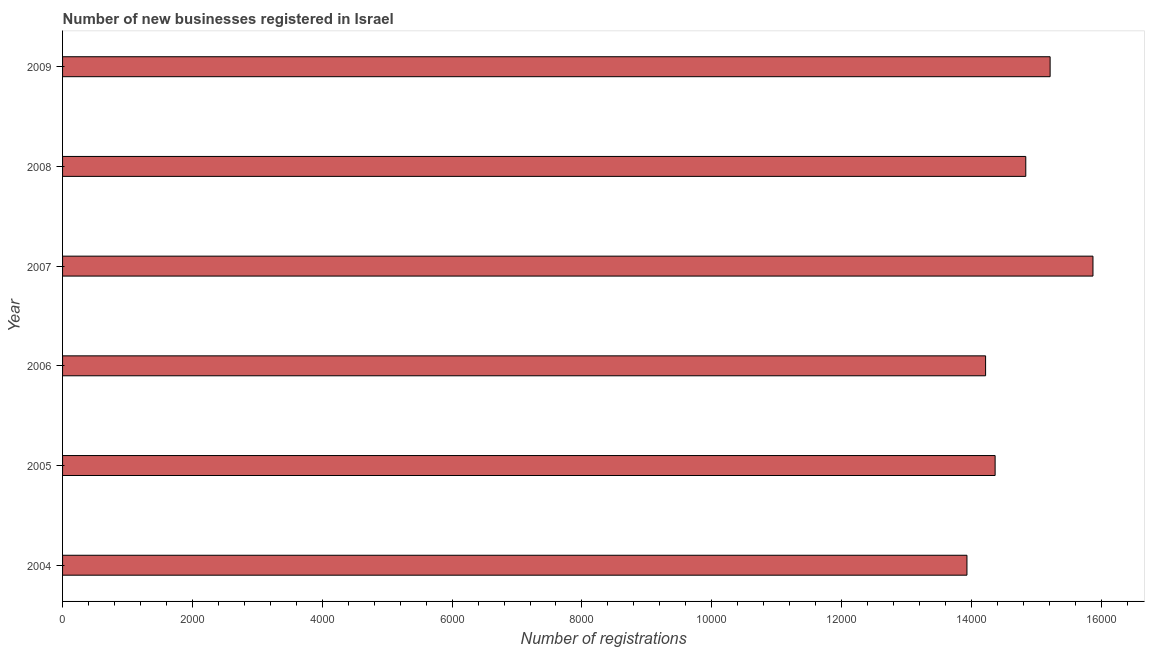Does the graph contain any zero values?
Provide a short and direct response. No. What is the title of the graph?
Ensure brevity in your answer.  Number of new businesses registered in Israel. What is the label or title of the X-axis?
Your response must be concise. Number of registrations. What is the number of new business registrations in 2006?
Your answer should be compact. 1.42e+04. Across all years, what is the maximum number of new business registrations?
Your answer should be very brief. 1.59e+04. Across all years, what is the minimum number of new business registrations?
Give a very brief answer. 1.39e+04. In which year was the number of new business registrations minimum?
Make the answer very short. 2004. What is the sum of the number of new business registrations?
Provide a short and direct response. 8.84e+04. What is the difference between the number of new business registrations in 2005 and 2008?
Ensure brevity in your answer.  -472. What is the average number of new business registrations per year?
Your response must be concise. 1.47e+04. What is the median number of new business registrations?
Offer a very short reply. 1.46e+04. Do a majority of the years between 2007 and 2005 (inclusive) have number of new business registrations greater than 2800 ?
Provide a short and direct response. Yes. Is the difference between the number of new business registrations in 2005 and 2007 greater than the difference between any two years?
Give a very brief answer. No. What is the difference between the highest and the second highest number of new business registrations?
Offer a very short reply. 660. What is the difference between the highest and the lowest number of new business registrations?
Offer a terse response. 1941. How many years are there in the graph?
Make the answer very short. 6. What is the difference between two consecutive major ticks on the X-axis?
Provide a short and direct response. 2000. Are the values on the major ticks of X-axis written in scientific E-notation?
Offer a very short reply. No. What is the Number of registrations in 2004?
Provide a succinct answer. 1.39e+04. What is the Number of registrations of 2005?
Offer a very short reply. 1.44e+04. What is the Number of registrations in 2006?
Offer a very short reply. 1.42e+04. What is the Number of registrations of 2007?
Provide a succinct answer. 1.59e+04. What is the Number of registrations of 2008?
Provide a succinct answer. 1.48e+04. What is the Number of registrations of 2009?
Keep it short and to the point. 1.52e+04. What is the difference between the Number of registrations in 2004 and 2005?
Provide a short and direct response. -434. What is the difference between the Number of registrations in 2004 and 2006?
Ensure brevity in your answer.  -287. What is the difference between the Number of registrations in 2004 and 2007?
Give a very brief answer. -1941. What is the difference between the Number of registrations in 2004 and 2008?
Offer a terse response. -906. What is the difference between the Number of registrations in 2004 and 2009?
Provide a succinct answer. -1281. What is the difference between the Number of registrations in 2005 and 2006?
Ensure brevity in your answer.  147. What is the difference between the Number of registrations in 2005 and 2007?
Offer a terse response. -1507. What is the difference between the Number of registrations in 2005 and 2008?
Your answer should be compact. -472. What is the difference between the Number of registrations in 2005 and 2009?
Offer a very short reply. -847. What is the difference between the Number of registrations in 2006 and 2007?
Give a very brief answer. -1654. What is the difference between the Number of registrations in 2006 and 2008?
Keep it short and to the point. -619. What is the difference between the Number of registrations in 2006 and 2009?
Offer a terse response. -994. What is the difference between the Number of registrations in 2007 and 2008?
Provide a succinct answer. 1035. What is the difference between the Number of registrations in 2007 and 2009?
Offer a very short reply. 660. What is the difference between the Number of registrations in 2008 and 2009?
Keep it short and to the point. -375. What is the ratio of the Number of registrations in 2004 to that in 2007?
Offer a very short reply. 0.88. What is the ratio of the Number of registrations in 2004 to that in 2008?
Your answer should be compact. 0.94. What is the ratio of the Number of registrations in 2004 to that in 2009?
Offer a very short reply. 0.92. What is the ratio of the Number of registrations in 2005 to that in 2006?
Ensure brevity in your answer.  1.01. What is the ratio of the Number of registrations in 2005 to that in 2007?
Ensure brevity in your answer.  0.91. What is the ratio of the Number of registrations in 2005 to that in 2008?
Ensure brevity in your answer.  0.97. What is the ratio of the Number of registrations in 2005 to that in 2009?
Offer a terse response. 0.94. What is the ratio of the Number of registrations in 2006 to that in 2007?
Offer a terse response. 0.9. What is the ratio of the Number of registrations in 2006 to that in 2008?
Give a very brief answer. 0.96. What is the ratio of the Number of registrations in 2006 to that in 2009?
Give a very brief answer. 0.94. What is the ratio of the Number of registrations in 2007 to that in 2008?
Give a very brief answer. 1.07. What is the ratio of the Number of registrations in 2007 to that in 2009?
Offer a very short reply. 1.04. What is the ratio of the Number of registrations in 2008 to that in 2009?
Make the answer very short. 0.97. 